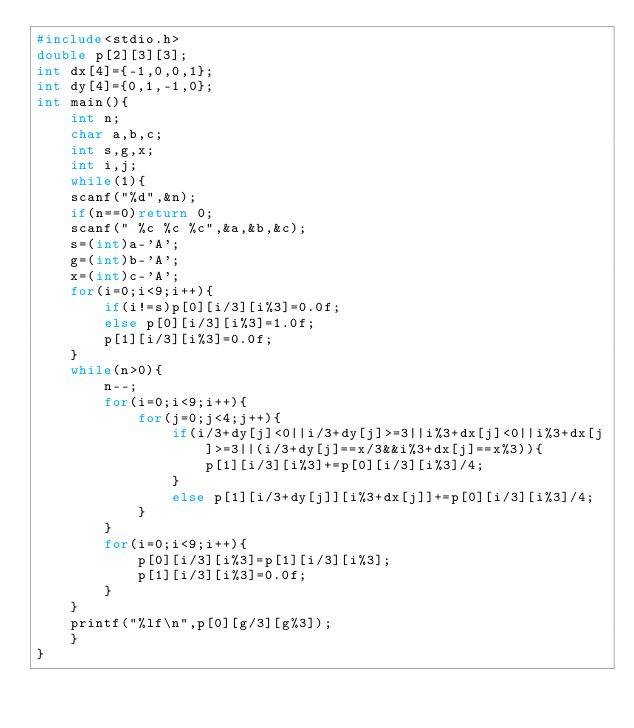Convert code to text. <code><loc_0><loc_0><loc_500><loc_500><_C_>#include<stdio.h>
double p[2][3][3];
int dx[4]={-1,0,0,1};
int dy[4]={0,1,-1,0};
int main(){
	int n;
	char a,b,c;
	int s,g,x;
	int i,j;
	while(1){
	scanf("%d",&n);
	if(n==0)return 0;
	scanf(" %c %c %c",&a,&b,&c);
	s=(int)a-'A';
	g=(int)b-'A';
	x=(int)c-'A';
	for(i=0;i<9;i++){
		if(i!=s)p[0][i/3][i%3]=0.0f;
		else p[0][i/3][i%3]=1.0f;
		p[1][i/3][i%3]=0.0f;
	}
	while(n>0){
		n--;
		for(i=0;i<9;i++){
			for(j=0;j<4;j++){
				if(i/3+dy[j]<0||i/3+dy[j]>=3||i%3+dx[j]<0||i%3+dx[j]>=3||(i/3+dy[j]==x/3&&i%3+dx[j]==x%3)){
					p[1][i/3][i%3]+=p[0][i/3][i%3]/4;
				}
				else p[1][i/3+dy[j]][i%3+dx[j]]+=p[0][i/3][i%3]/4;
			}
		}
		for(i=0;i<9;i++){
			p[0][i/3][i%3]=p[1][i/3][i%3];
			p[1][i/3][i%3]=0.0f;
		}
	}
	printf("%lf\n",p[0][g/3][g%3]);
	}	
}
	</code> 